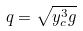<formula> <loc_0><loc_0><loc_500><loc_500>q = \sqrt { y _ { c } ^ { 3 } g }</formula> 